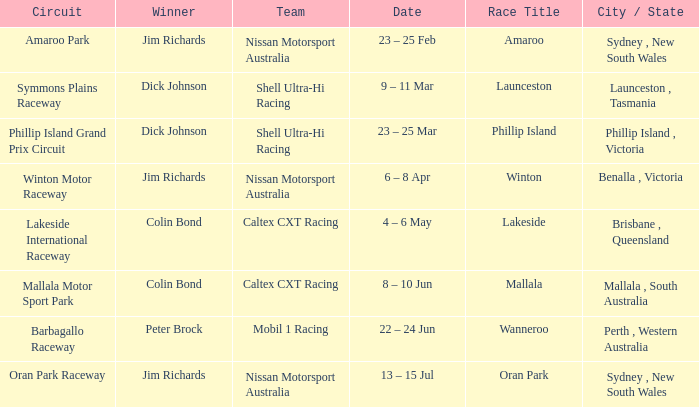Name the team for launceston Shell Ultra-Hi Racing. 